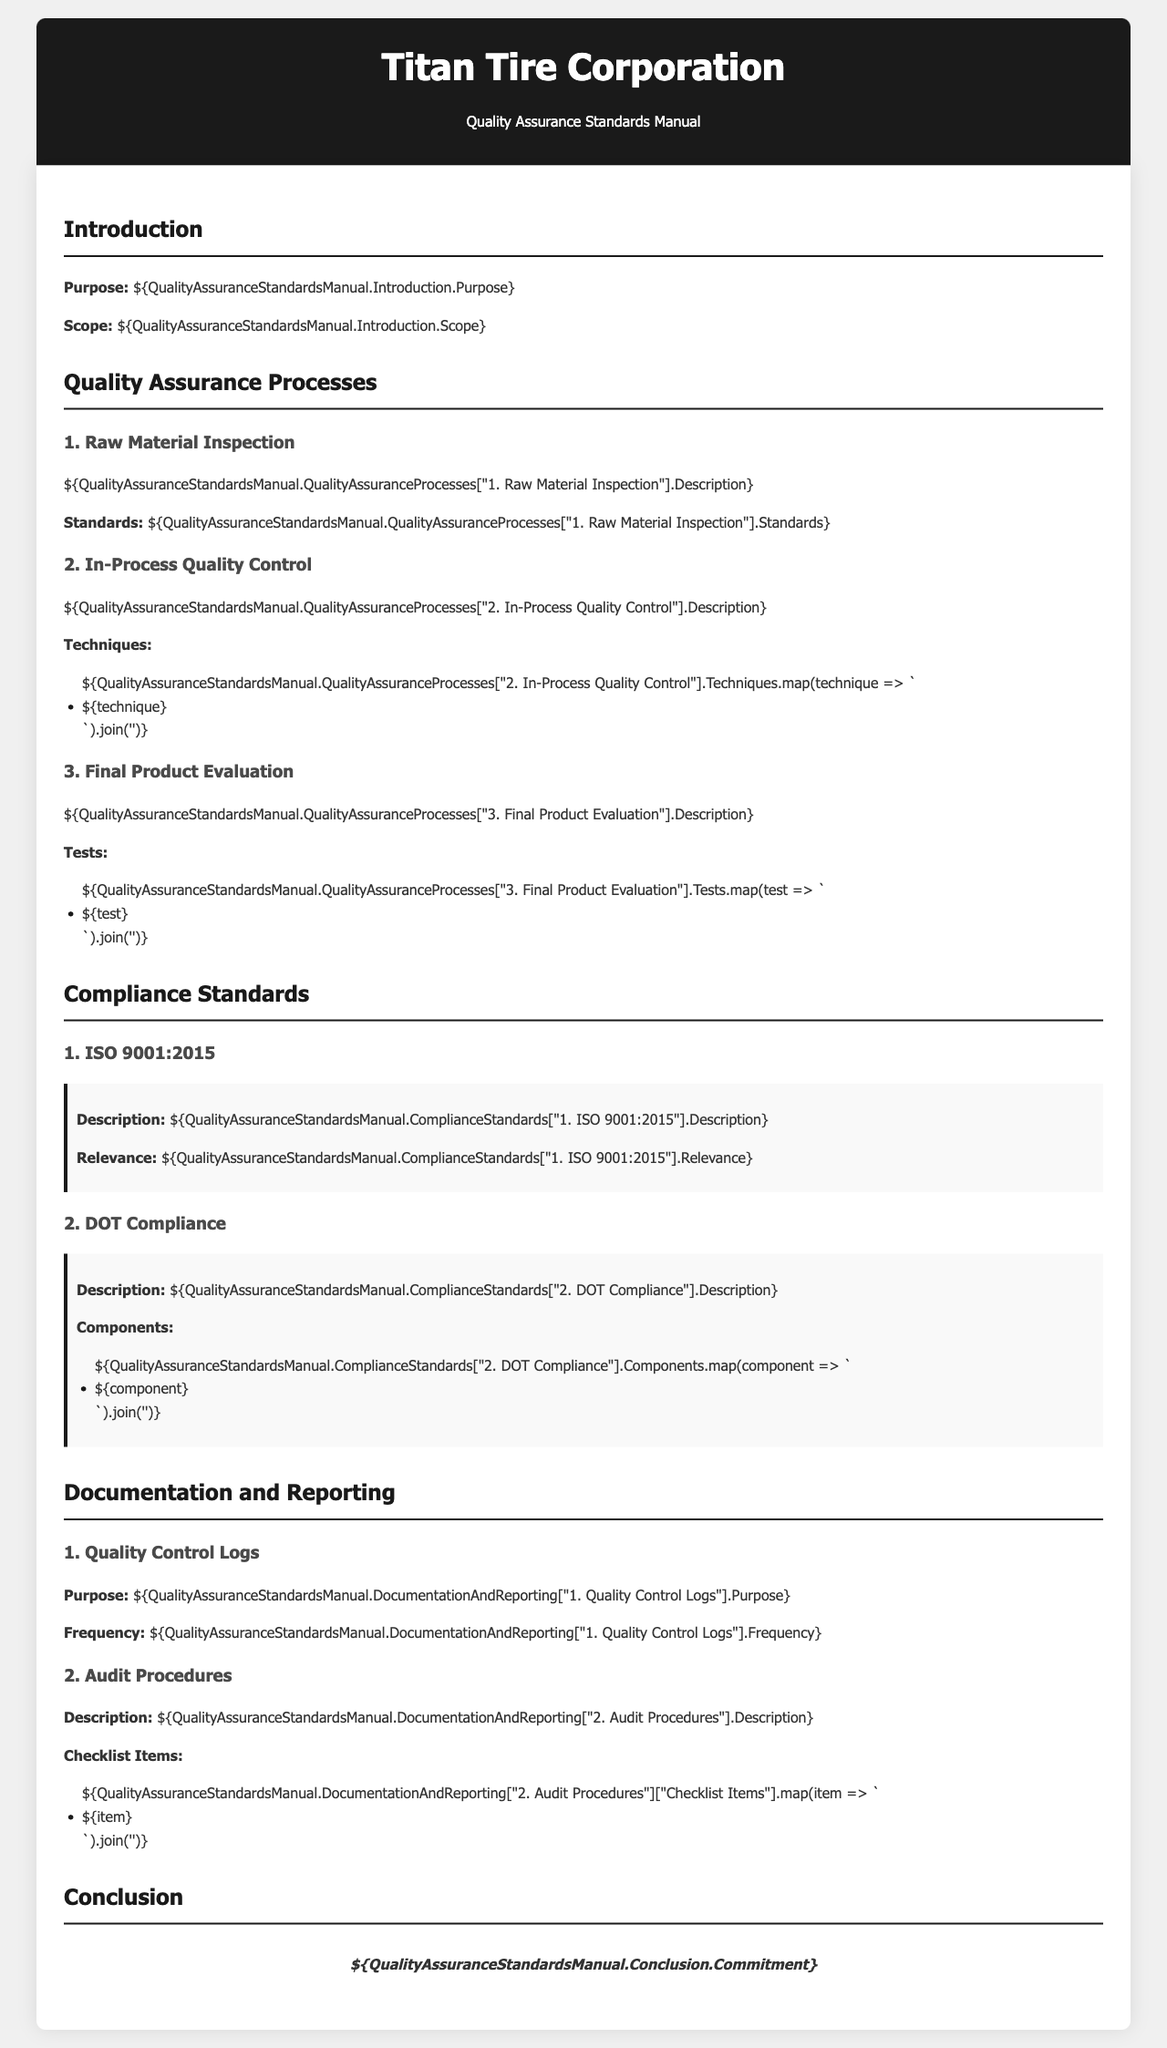what is the purpose of the quality assurance manual? The purpose is to outline the quality assurance processes and standards implemented in the manufacturing facilities.
Answer: outline of quality assurance processes and standards what is the scope of the quality assurance manual? The scope defines the context and applicability of the quality assurance standards within the organization.
Answer: context and applicability what is the first process in the quality assurance section? The first process outlined is Raw Material Inspection.
Answer: Raw Material Inspection how many techniques are listed for In-Process Quality Control? The number of techniques listed for In-Process Quality Control is directly provided in the document.
Answer: - (specific number can’t be derived without the data) what is the compliance standard associated with ISO? The compliance standard associated is ISO 9001:2015.
Answer: ISO 9001:2015 what is required for DOT Compliance? Components of DOT Compliance are listed to ensure compliance with safety regulations.
Answer: listed components how often are quality control logs reviewed? The frequency of reviewing quality control logs is specified in the document.
Answer: - (specific frequency can’t be derived without the data) what are the checklist items in the audit procedures focused on? The checklist items focus on specific criteria for evaluating quality assurance processes.
Answer: specific criteria what is the overarching commitment mentioned in the conclusion? The conclusion illustrates the commitment to quality assurance throughout the manufacturing process.
Answer: commitment to quality assurance 